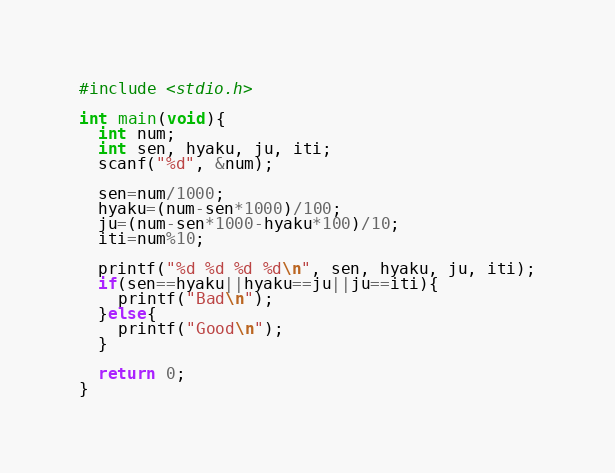<code> <loc_0><loc_0><loc_500><loc_500><_C_>#include <stdio.h>

int main(void){
  int num;
  int sen, hyaku, ju, iti;
  scanf("%d", &num);

  sen=num/1000;
  hyaku=(num-sen*1000)/100;
  ju=(num-sen*1000-hyaku*100)/10;
  iti=num%10;

  printf("%d %d %d %d\n", sen, hyaku, ju, iti);
  if(sen==hyaku||hyaku==ju||ju==iti){
    printf("Bad\n");
  }else{
    printf("Good\n");
  }

  return 0;
}
</code> 